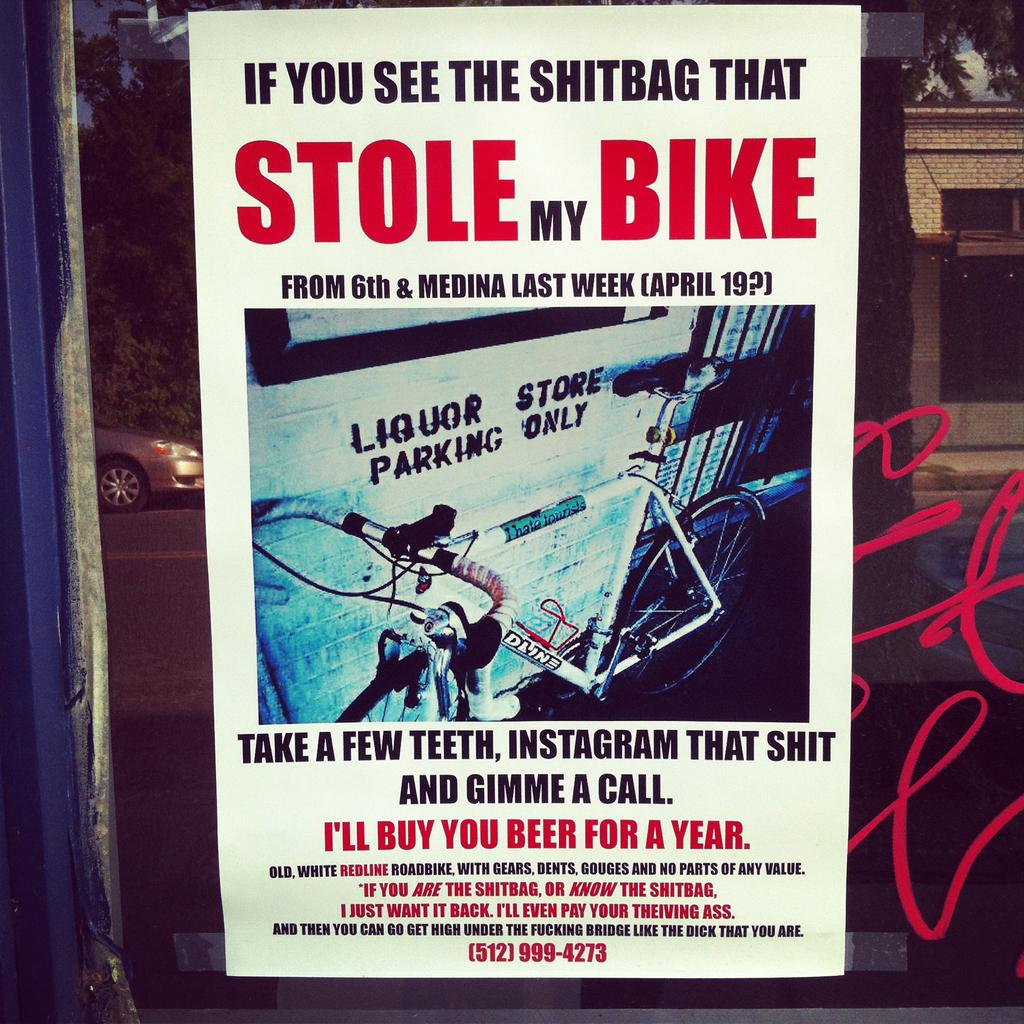<image>
Summarize the visual content of the image. Poster of a bike that was stolen from its owner and text saying that he will buy you beer for a year. 